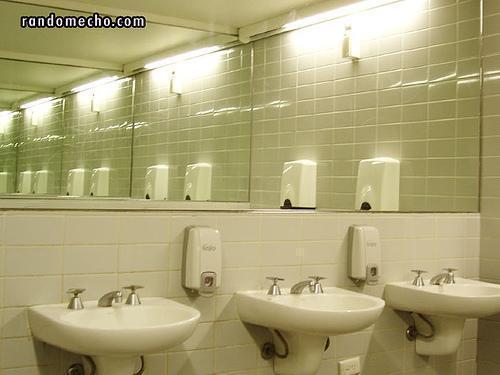How many sinks are there?
Indicate the correct response by choosing from the four available options to answer the question.
Options: Six, three, four, five. Three. 